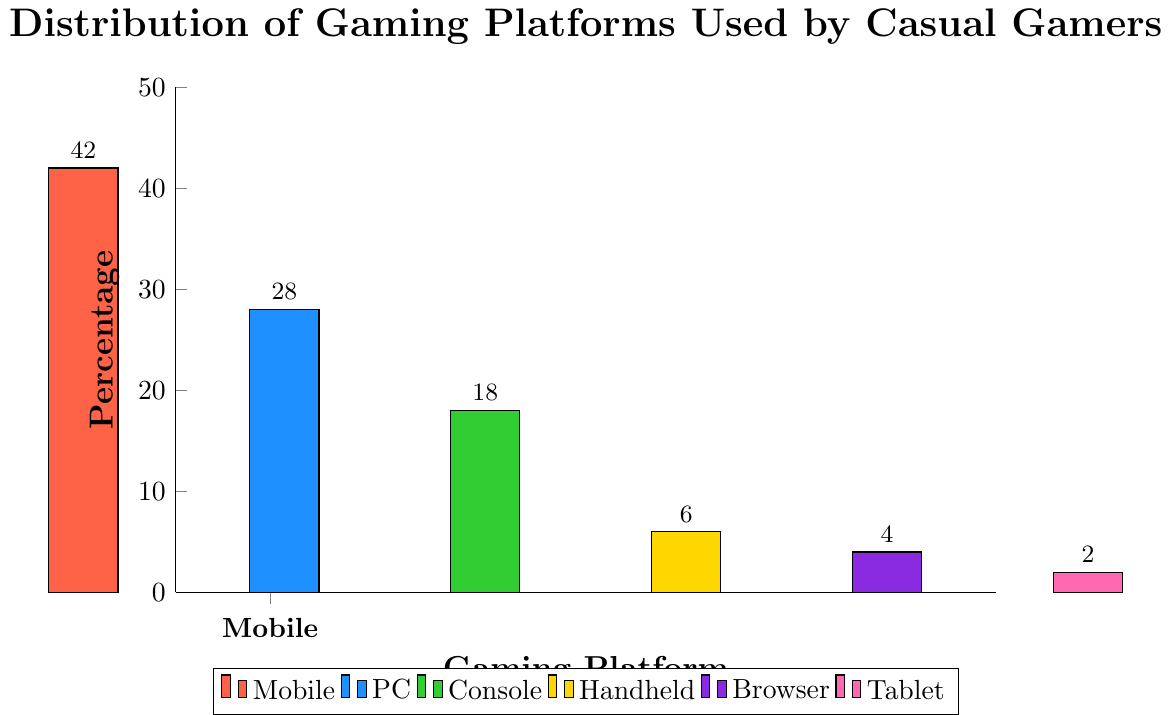What percentage of casual gamers use PC or Console platforms? First, find the percentages for PC and Console. PC is 28% and Console is 18%. Add these two percentages: 28 + 18 = 46%
Answer: 46% Which platform is used by the least number of casual gamers? Look at the y-axis values of all bars and determine the smallest value. The Tablet platform has the lowest percentage, which is 2%
Answer: Tablet How much greater is the percentage of Mobile users compared to Handheld users? First, find the percentage of Mobile users (42%) and Handheld users (6%). Subtract the Handheld percentage from the Mobile percentage: 42 - 6 = 36%
Answer: 36% What is the average percentage of gamers using Handheld, Browser, and Tablet platforms combined? First, find the sum of Handheld (6%), Browser (4%), and Tablet (2%): 6 + 4 + 2 = 12%. Then, divide this sum by the number of platforms (3): 12 / 3 = 4%
Answer: 4% Does the percentage of Console users exceed Browser and Tablet users combined? Sum the percentages for Browser (4%) and Tablet (2%): 4 + 2 = 6%. The percentage for Console users is 18%. Compare the two sums: 18 > 6
Answer: Yes What is the difference in the percentage of PC and Browser users? Find the percentages for PC (28%) and Browser (4%). Subtract the Browser percentage from the PC percentage: 28 - 4 = 24%
Answer: 24% Which platform shows up as a yellow bar in the chart? Identify the platform color for the yellow bar by visually inspecting the chart. The Handheld platform is represented by the yellow bar
Answer: Handheld What percentage of gamers use platforms other than Mobile? First, sum the percentages of all platforms except Mobile: PC (28%) + Console (18%) + Handheld (6%) + Browser (4%) + Tablet (2%), which totals 28 + 18 + 6 + 4 + 2 = 58%
Answer: 58% Among Mobile, PC, and Console, which platform is the second most popular? Compare the percentages of Mobile (42%), PC (28%), and Console (18%). The second highest percentage is PC with 28%
Answer: PC 